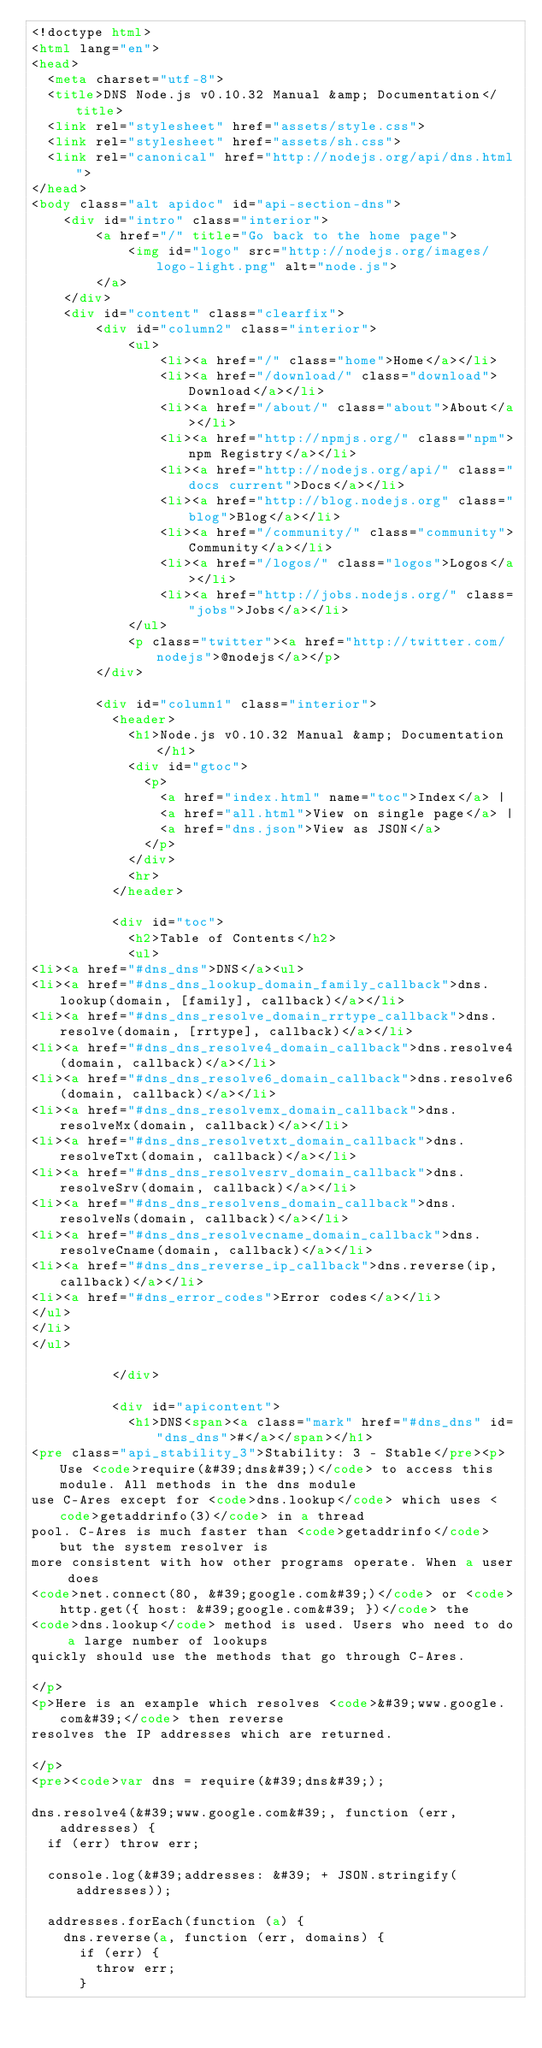Convert code to text. <code><loc_0><loc_0><loc_500><loc_500><_HTML_><!doctype html>
<html lang="en">
<head>
  <meta charset="utf-8">
  <title>DNS Node.js v0.10.32 Manual &amp; Documentation</title>
  <link rel="stylesheet" href="assets/style.css">
  <link rel="stylesheet" href="assets/sh.css">
  <link rel="canonical" href="http://nodejs.org/api/dns.html">
</head>
<body class="alt apidoc" id="api-section-dns">
    <div id="intro" class="interior">
        <a href="/" title="Go back to the home page">
            <img id="logo" src="http://nodejs.org/images/logo-light.png" alt="node.js">
        </a>
    </div>
    <div id="content" class="clearfix">
        <div id="column2" class="interior">
            <ul>
                <li><a href="/" class="home">Home</a></li>
                <li><a href="/download/" class="download">Download</a></li>
                <li><a href="/about/" class="about">About</a></li>
                <li><a href="http://npmjs.org/" class="npm">npm Registry</a></li>
                <li><a href="http://nodejs.org/api/" class="docs current">Docs</a></li>
                <li><a href="http://blog.nodejs.org" class="blog">Blog</a></li>
                <li><a href="/community/" class="community">Community</a></li>
                <li><a href="/logos/" class="logos">Logos</a></li>
                <li><a href="http://jobs.nodejs.org/" class="jobs">Jobs</a></li>
            </ul>
            <p class="twitter"><a href="http://twitter.com/nodejs">@nodejs</a></p>
        </div>

        <div id="column1" class="interior">
          <header>
            <h1>Node.js v0.10.32 Manual &amp; Documentation</h1>
            <div id="gtoc">
              <p>
                <a href="index.html" name="toc">Index</a> |
                <a href="all.html">View on single page</a> |
                <a href="dns.json">View as JSON</a>
              </p>
            </div>
            <hr>
          </header>

          <div id="toc">
            <h2>Table of Contents</h2>
            <ul>
<li><a href="#dns_dns">DNS</a><ul>
<li><a href="#dns_dns_lookup_domain_family_callback">dns.lookup(domain, [family], callback)</a></li>
<li><a href="#dns_dns_resolve_domain_rrtype_callback">dns.resolve(domain, [rrtype], callback)</a></li>
<li><a href="#dns_dns_resolve4_domain_callback">dns.resolve4(domain, callback)</a></li>
<li><a href="#dns_dns_resolve6_domain_callback">dns.resolve6(domain, callback)</a></li>
<li><a href="#dns_dns_resolvemx_domain_callback">dns.resolveMx(domain, callback)</a></li>
<li><a href="#dns_dns_resolvetxt_domain_callback">dns.resolveTxt(domain, callback)</a></li>
<li><a href="#dns_dns_resolvesrv_domain_callback">dns.resolveSrv(domain, callback)</a></li>
<li><a href="#dns_dns_resolvens_domain_callback">dns.resolveNs(domain, callback)</a></li>
<li><a href="#dns_dns_resolvecname_domain_callback">dns.resolveCname(domain, callback)</a></li>
<li><a href="#dns_dns_reverse_ip_callback">dns.reverse(ip, callback)</a></li>
<li><a href="#dns_error_codes">Error codes</a></li>
</ul>
</li>
</ul>

          </div>

          <div id="apicontent">
            <h1>DNS<span><a class="mark" href="#dns_dns" id="dns_dns">#</a></span></h1>
<pre class="api_stability_3">Stability: 3 - Stable</pre><p>Use <code>require(&#39;dns&#39;)</code> to access this module. All methods in the dns module
use C-Ares except for <code>dns.lookup</code> which uses <code>getaddrinfo(3)</code> in a thread
pool. C-Ares is much faster than <code>getaddrinfo</code> but the system resolver is
more consistent with how other programs operate. When a user does
<code>net.connect(80, &#39;google.com&#39;)</code> or <code>http.get({ host: &#39;google.com&#39; })</code> the
<code>dns.lookup</code> method is used. Users who need to do a large number of lookups
quickly should use the methods that go through C-Ares.

</p>
<p>Here is an example which resolves <code>&#39;www.google.com&#39;</code> then reverse
resolves the IP addresses which are returned.

</p>
<pre><code>var dns = require(&#39;dns&#39;);

dns.resolve4(&#39;www.google.com&#39;, function (err, addresses) {
  if (err) throw err;

  console.log(&#39;addresses: &#39; + JSON.stringify(addresses));

  addresses.forEach(function (a) {
    dns.reverse(a, function (err, domains) {
      if (err) {
        throw err;
      }
</code> 